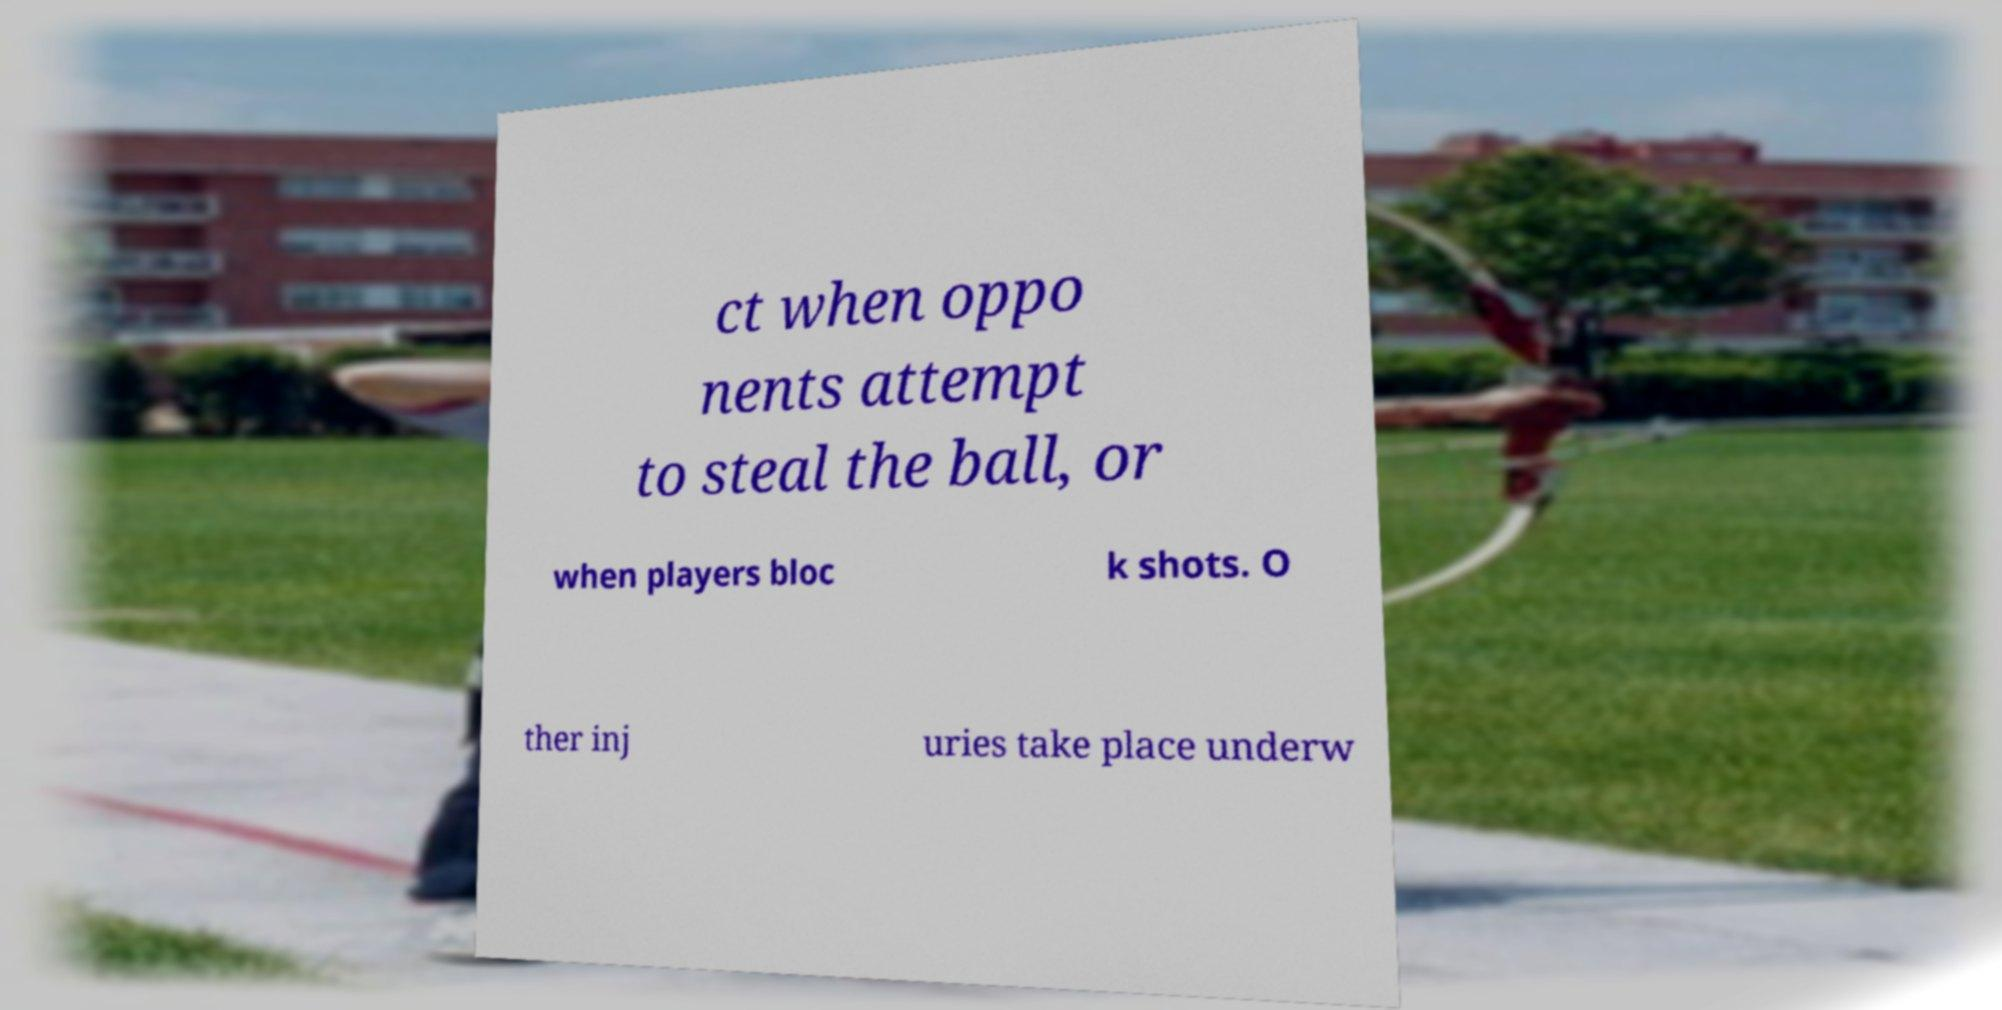For documentation purposes, I need the text within this image transcribed. Could you provide that? ct when oppo nents attempt to steal the ball, or when players bloc k shots. O ther inj uries take place underw 